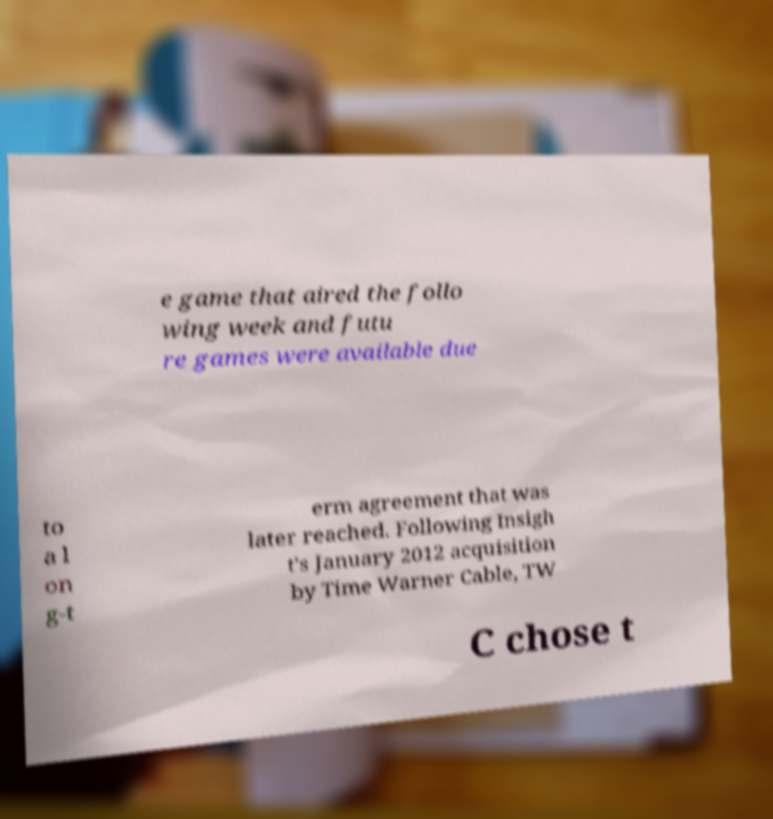There's text embedded in this image that I need extracted. Can you transcribe it verbatim? e game that aired the follo wing week and futu re games were available due to a l on g-t erm agreement that was later reached. Following Insigh t's January 2012 acquisition by Time Warner Cable, TW C chose t 